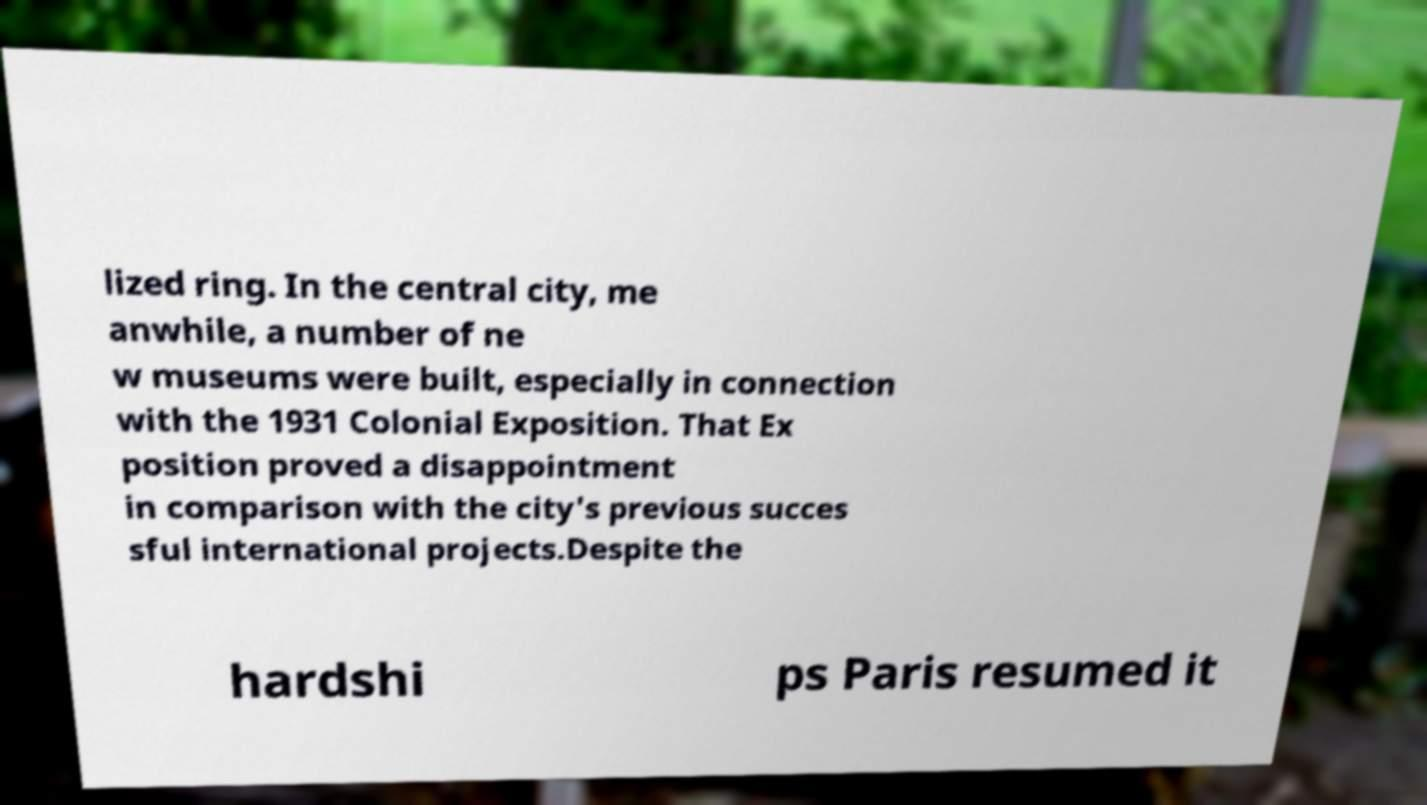There's text embedded in this image that I need extracted. Can you transcribe it verbatim? lized ring. In the central city, me anwhile, a number of ne w museums were built, especially in connection with the 1931 Colonial Exposition. That Ex position proved a disappointment in comparison with the city's previous succes sful international projects.Despite the hardshi ps Paris resumed it 